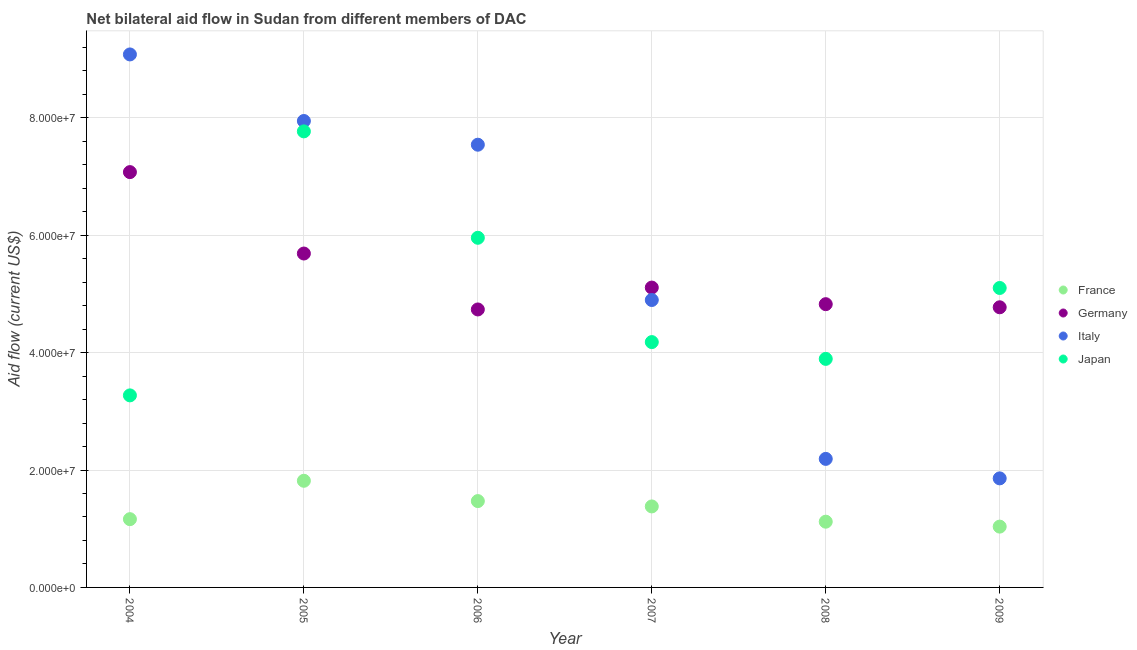How many different coloured dotlines are there?
Ensure brevity in your answer.  4. What is the amount of aid given by germany in 2005?
Your answer should be very brief. 5.69e+07. Across all years, what is the maximum amount of aid given by france?
Your response must be concise. 1.82e+07. Across all years, what is the minimum amount of aid given by germany?
Your answer should be very brief. 4.74e+07. In which year was the amount of aid given by japan maximum?
Give a very brief answer. 2005. What is the total amount of aid given by germany in the graph?
Offer a terse response. 3.22e+08. What is the difference between the amount of aid given by japan in 2005 and that in 2008?
Offer a terse response. 3.88e+07. What is the difference between the amount of aid given by japan in 2008 and the amount of aid given by germany in 2004?
Your answer should be compact. -3.18e+07. What is the average amount of aid given by germany per year?
Your answer should be compact. 5.37e+07. In the year 2004, what is the difference between the amount of aid given by germany and amount of aid given by japan?
Make the answer very short. 3.80e+07. What is the ratio of the amount of aid given by italy in 2006 to that in 2008?
Keep it short and to the point. 3.44. Is the amount of aid given by italy in 2005 less than that in 2006?
Provide a succinct answer. No. What is the difference between the highest and the second highest amount of aid given by germany?
Provide a succinct answer. 1.39e+07. What is the difference between the highest and the lowest amount of aid given by france?
Make the answer very short. 7.81e+06. In how many years, is the amount of aid given by france greater than the average amount of aid given by france taken over all years?
Give a very brief answer. 3. Is it the case that in every year, the sum of the amount of aid given by japan and amount of aid given by france is greater than the sum of amount of aid given by italy and amount of aid given by germany?
Give a very brief answer. No. Does the amount of aid given by japan monotonically increase over the years?
Give a very brief answer. No. How many dotlines are there?
Provide a short and direct response. 4. How many years are there in the graph?
Make the answer very short. 6. Are the values on the major ticks of Y-axis written in scientific E-notation?
Provide a succinct answer. Yes. Does the graph contain grids?
Make the answer very short. Yes. What is the title of the graph?
Your answer should be very brief. Net bilateral aid flow in Sudan from different members of DAC. Does "Secondary vocational education" appear as one of the legend labels in the graph?
Keep it short and to the point. No. What is the Aid flow (current US$) of France in 2004?
Provide a succinct answer. 1.16e+07. What is the Aid flow (current US$) in Germany in 2004?
Offer a terse response. 7.08e+07. What is the Aid flow (current US$) in Italy in 2004?
Make the answer very short. 9.08e+07. What is the Aid flow (current US$) in Japan in 2004?
Provide a succinct answer. 3.27e+07. What is the Aid flow (current US$) of France in 2005?
Your answer should be very brief. 1.82e+07. What is the Aid flow (current US$) in Germany in 2005?
Ensure brevity in your answer.  5.69e+07. What is the Aid flow (current US$) of Italy in 2005?
Provide a short and direct response. 7.95e+07. What is the Aid flow (current US$) of Japan in 2005?
Your response must be concise. 7.77e+07. What is the Aid flow (current US$) in France in 2006?
Make the answer very short. 1.47e+07. What is the Aid flow (current US$) of Germany in 2006?
Provide a short and direct response. 4.74e+07. What is the Aid flow (current US$) of Italy in 2006?
Ensure brevity in your answer.  7.54e+07. What is the Aid flow (current US$) in Japan in 2006?
Provide a short and direct response. 5.96e+07. What is the Aid flow (current US$) in France in 2007?
Offer a very short reply. 1.38e+07. What is the Aid flow (current US$) in Germany in 2007?
Give a very brief answer. 5.11e+07. What is the Aid flow (current US$) of Italy in 2007?
Give a very brief answer. 4.90e+07. What is the Aid flow (current US$) of Japan in 2007?
Provide a short and direct response. 4.18e+07. What is the Aid flow (current US$) in France in 2008?
Provide a succinct answer. 1.12e+07. What is the Aid flow (current US$) in Germany in 2008?
Provide a short and direct response. 4.83e+07. What is the Aid flow (current US$) of Italy in 2008?
Your answer should be compact. 2.19e+07. What is the Aid flow (current US$) in Japan in 2008?
Offer a terse response. 3.89e+07. What is the Aid flow (current US$) of France in 2009?
Give a very brief answer. 1.04e+07. What is the Aid flow (current US$) of Germany in 2009?
Offer a terse response. 4.77e+07. What is the Aid flow (current US$) of Italy in 2009?
Offer a very short reply. 1.86e+07. What is the Aid flow (current US$) of Japan in 2009?
Keep it short and to the point. 5.10e+07. Across all years, what is the maximum Aid flow (current US$) of France?
Keep it short and to the point. 1.82e+07. Across all years, what is the maximum Aid flow (current US$) in Germany?
Provide a short and direct response. 7.08e+07. Across all years, what is the maximum Aid flow (current US$) in Italy?
Provide a succinct answer. 9.08e+07. Across all years, what is the maximum Aid flow (current US$) in Japan?
Make the answer very short. 7.77e+07. Across all years, what is the minimum Aid flow (current US$) of France?
Ensure brevity in your answer.  1.04e+07. Across all years, what is the minimum Aid flow (current US$) in Germany?
Provide a short and direct response. 4.74e+07. Across all years, what is the minimum Aid flow (current US$) of Italy?
Offer a terse response. 1.86e+07. Across all years, what is the minimum Aid flow (current US$) in Japan?
Ensure brevity in your answer.  3.27e+07. What is the total Aid flow (current US$) of France in the graph?
Provide a short and direct response. 7.99e+07. What is the total Aid flow (current US$) of Germany in the graph?
Provide a short and direct response. 3.22e+08. What is the total Aid flow (current US$) in Italy in the graph?
Your response must be concise. 3.35e+08. What is the total Aid flow (current US$) of Japan in the graph?
Your response must be concise. 3.02e+08. What is the difference between the Aid flow (current US$) in France in 2004 and that in 2005?
Provide a short and direct response. -6.54e+06. What is the difference between the Aid flow (current US$) of Germany in 2004 and that in 2005?
Give a very brief answer. 1.39e+07. What is the difference between the Aid flow (current US$) in Italy in 2004 and that in 2005?
Make the answer very short. 1.13e+07. What is the difference between the Aid flow (current US$) of Japan in 2004 and that in 2005?
Keep it short and to the point. -4.50e+07. What is the difference between the Aid flow (current US$) of France in 2004 and that in 2006?
Your answer should be very brief. -3.08e+06. What is the difference between the Aid flow (current US$) in Germany in 2004 and that in 2006?
Your answer should be compact. 2.34e+07. What is the difference between the Aid flow (current US$) of Italy in 2004 and that in 2006?
Your answer should be compact. 1.54e+07. What is the difference between the Aid flow (current US$) in Japan in 2004 and that in 2006?
Offer a very short reply. -2.68e+07. What is the difference between the Aid flow (current US$) of France in 2004 and that in 2007?
Offer a terse response. -2.17e+06. What is the difference between the Aid flow (current US$) of Germany in 2004 and that in 2007?
Offer a very short reply. 1.97e+07. What is the difference between the Aid flow (current US$) in Italy in 2004 and that in 2007?
Make the answer very short. 4.18e+07. What is the difference between the Aid flow (current US$) of Japan in 2004 and that in 2007?
Your answer should be very brief. -9.08e+06. What is the difference between the Aid flow (current US$) of France in 2004 and that in 2008?
Offer a very short reply. 4.30e+05. What is the difference between the Aid flow (current US$) of Germany in 2004 and that in 2008?
Ensure brevity in your answer.  2.25e+07. What is the difference between the Aid flow (current US$) of Italy in 2004 and that in 2008?
Give a very brief answer. 6.89e+07. What is the difference between the Aid flow (current US$) of Japan in 2004 and that in 2008?
Offer a very short reply. -6.22e+06. What is the difference between the Aid flow (current US$) in France in 2004 and that in 2009?
Give a very brief answer. 1.27e+06. What is the difference between the Aid flow (current US$) in Germany in 2004 and that in 2009?
Provide a succinct answer. 2.30e+07. What is the difference between the Aid flow (current US$) in Italy in 2004 and that in 2009?
Your response must be concise. 7.22e+07. What is the difference between the Aid flow (current US$) of Japan in 2004 and that in 2009?
Keep it short and to the point. -1.83e+07. What is the difference between the Aid flow (current US$) of France in 2005 and that in 2006?
Make the answer very short. 3.46e+06. What is the difference between the Aid flow (current US$) of Germany in 2005 and that in 2006?
Your answer should be compact. 9.53e+06. What is the difference between the Aid flow (current US$) in Italy in 2005 and that in 2006?
Provide a succinct answer. 4.04e+06. What is the difference between the Aid flow (current US$) in Japan in 2005 and that in 2006?
Your answer should be very brief. 1.81e+07. What is the difference between the Aid flow (current US$) in France in 2005 and that in 2007?
Your answer should be very brief. 4.37e+06. What is the difference between the Aid flow (current US$) of Germany in 2005 and that in 2007?
Keep it short and to the point. 5.80e+06. What is the difference between the Aid flow (current US$) in Italy in 2005 and that in 2007?
Make the answer very short. 3.05e+07. What is the difference between the Aid flow (current US$) of Japan in 2005 and that in 2007?
Your answer should be compact. 3.59e+07. What is the difference between the Aid flow (current US$) of France in 2005 and that in 2008?
Your answer should be very brief. 6.97e+06. What is the difference between the Aid flow (current US$) in Germany in 2005 and that in 2008?
Give a very brief answer. 8.63e+06. What is the difference between the Aid flow (current US$) of Italy in 2005 and that in 2008?
Your answer should be very brief. 5.76e+07. What is the difference between the Aid flow (current US$) in Japan in 2005 and that in 2008?
Keep it short and to the point. 3.88e+07. What is the difference between the Aid flow (current US$) of France in 2005 and that in 2009?
Give a very brief answer. 7.81e+06. What is the difference between the Aid flow (current US$) of Germany in 2005 and that in 2009?
Give a very brief answer. 9.16e+06. What is the difference between the Aid flow (current US$) in Italy in 2005 and that in 2009?
Offer a very short reply. 6.09e+07. What is the difference between the Aid flow (current US$) in Japan in 2005 and that in 2009?
Ensure brevity in your answer.  2.67e+07. What is the difference between the Aid flow (current US$) of France in 2006 and that in 2007?
Ensure brevity in your answer.  9.10e+05. What is the difference between the Aid flow (current US$) in Germany in 2006 and that in 2007?
Provide a succinct answer. -3.73e+06. What is the difference between the Aid flow (current US$) of Italy in 2006 and that in 2007?
Offer a terse response. 2.65e+07. What is the difference between the Aid flow (current US$) in Japan in 2006 and that in 2007?
Keep it short and to the point. 1.78e+07. What is the difference between the Aid flow (current US$) in France in 2006 and that in 2008?
Give a very brief answer. 3.51e+06. What is the difference between the Aid flow (current US$) in Germany in 2006 and that in 2008?
Make the answer very short. -9.00e+05. What is the difference between the Aid flow (current US$) in Italy in 2006 and that in 2008?
Offer a very short reply. 5.35e+07. What is the difference between the Aid flow (current US$) in Japan in 2006 and that in 2008?
Provide a short and direct response. 2.06e+07. What is the difference between the Aid flow (current US$) of France in 2006 and that in 2009?
Your answer should be compact. 4.35e+06. What is the difference between the Aid flow (current US$) of Germany in 2006 and that in 2009?
Give a very brief answer. -3.70e+05. What is the difference between the Aid flow (current US$) of Italy in 2006 and that in 2009?
Your response must be concise. 5.68e+07. What is the difference between the Aid flow (current US$) of Japan in 2006 and that in 2009?
Offer a very short reply. 8.55e+06. What is the difference between the Aid flow (current US$) in France in 2007 and that in 2008?
Your answer should be compact. 2.60e+06. What is the difference between the Aid flow (current US$) of Germany in 2007 and that in 2008?
Keep it short and to the point. 2.83e+06. What is the difference between the Aid flow (current US$) in Italy in 2007 and that in 2008?
Offer a terse response. 2.71e+07. What is the difference between the Aid flow (current US$) of Japan in 2007 and that in 2008?
Give a very brief answer. 2.86e+06. What is the difference between the Aid flow (current US$) in France in 2007 and that in 2009?
Give a very brief answer. 3.44e+06. What is the difference between the Aid flow (current US$) of Germany in 2007 and that in 2009?
Your answer should be very brief. 3.36e+06. What is the difference between the Aid flow (current US$) in Italy in 2007 and that in 2009?
Keep it short and to the point. 3.04e+07. What is the difference between the Aid flow (current US$) in Japan in 2007 and that in 2009?
Provide a short and direct response. -9.22e+06. What is the difference between the Aid flow (current US$) in France in 2008 and that in 2009?
Your answer should be compact. 8.40e+05. What is the difference between the Aid flow (current US$) in Germany in 2008 and that in 2009?
Offer a terse response. 5.30e+05. What is the difference between the Aid flow (current US$) of Italy in 2008 and that in 2009?
Your answer should be very brief. 3.32e+06. What is the difference between the Aid flow (current US$) of Japan in 2008 and that in 2009?
Keep it short and to the point. -1.21e+07. What is the difference between the Aid flow (current US$) of France in 2004 and the Aid flow (current US$) of Germany in 2005?
Your answer should be very brief. -4.53e+07. What is the difference between the Aid flow (current US$) of France in 2004 and the Aid flow (current US$) of Italy in 2005?
Ensure brevity in your answer.  -6.78e+07. What is the difference between the Aid flow (current US$) in France in 2004 and the Aid flow (current US$) in Japan in 2005?
Ensure brevity in your answer.  -6.61e+07. What is the difference between the Aid flow (current US$) in Germany in 2004 and the Aid flow (current US$) in Italy in 2005?
Keep it short and to the point. -8.71e+06. What is the difference between the Aid flow (current US$) of Germany in 2004 and the Aid flow (current US$) of Japan in 2005?
Give a very brief answer. -6.94e+06. What is the difference between the Aid flow (current US$) of Italy in 2004 and the Aid flow (current US$) of Japan in 2005?
Give a very brief answer. 1.31e+07. What is the difference between the Aid flow (current US$) of France in 2004 and the Aid flow (current US$) of Germany in 2006?
Your response must be concise. -3.57e+07. What is the difference between the Aid flow (current US$) of France in 2004 and the Aid flow (current US$) of Italy in 2006?
Your response must be concise. -6.38e+07. What is the difference between the Aid flow (current US$) of France in 2004 and the Aid flow (current US$) of Japan in 2006?
Provide a short and direct response. -4.79e+07. What is the difference between the Aid flow (current US$) of Germany in 2004 and the Aid flow (current US$) of Italy in 2006?
Keep it short and to the point. -4.67e+06. What is the difference between the Aid flow (current US$) in Germany in 2004 and the Aid flow (current US$) in Japan in 2006?
Provide a succinct answer. 1.12e+07. What is the difference between the Aid flow (current US$) in Italy in 2004 and the Aid flow (current US$) in Japan in 2006?
Offer a terse response. 3.12e+07. What is the difference between the Aid flow (current US$) of France in 2004 and the Aid flow (current US$) of Germany in 2007?
Give a very brief answer. -3.95e+07. What is the difference between the Aid flow (current US$) of France in 2004 and the Aid flow (current US$) of Italy in 2007?
Your answer should be compact. -3.73e+07. What is the difference between the Aid flow (current US$) of France in 2004 and the Aid flow (current US$) of Japan in 2007?
Your answer should be very brief. -3.02e+07. What is the difference between the Aid flow (current US$) in Germany in 2004 and the Aid flow (current US$) in Italy in 2007?
Give a very brief answer. 2.18e+07. What is the difference between the Aid flow (current US$) in Germany in 2004 and the Aid flow (current US$) in Japan in 2007?
Make the answer very short. 2.90e+07. What is the difference between the Aid flow (current US$) of Italy in 2004 and the Aid flow (current US$) of Japan in 2007?
Provide a succinct answer. 4.90e+07. What is the difference between the Aid flow (current US$) in France in 2004 and the Aid flow (current US$) in Germany in 2008?
Keep it short and to the point. -3.66e+07. What is the difference between the Aid flow (current US$) of France in 2004 and the Aid flow (current US$) of Italy in 2008?
Keep it short and to the point. -1.03e+07. What is the difference between the Aid flow (current US$) of France in 2004 and the Aid flow (current US$) of Japan in 2008?
Offer a terse response. -2.73e+07. What is the difference between the Aid flow (current US$) of Germany in 2004 and the Aid flow (current US$) of Italy in 2008?
Offer a very short reply. 4.89e+07. What is the difference between the Aid flow (current US$) of Germany in 2004 and the Aid flow (current US$) of Japan in 2008?
Keep it short and to the point. 3.18e+07. What is the difference between the Aid flow (current US$) of Italy in 2004 and the Aid flow (current US$) of Japan in 2008?
Your answer should be very brief. 5.19e+07. What is the difference between the Aid flow (current US$) in France in 2004 and the Aid flow (current US$) in Germany in 2009?
Provide a succinct answer. -3.61e+07. What is the difference between the Aid flow (current US$) in France in 2004 and the Aid flow (current US$) in Italy in 2009?
Your response must be concise. -6.95e+06. What is the difference between the Aid flow (current US$) of France in 2004 and the Aid flow (current US$) of Japan in 2009?
Provide a succinct answer. -3.94e+07. What is the difference between the Aid flow (current US$) in Germany in 2004 and the Aid flow (current US$) in Italy in 2009?
Offer a very short reply. 5.22e+07. What is the difference between the Aid flow (current US$) in Germany in 2004 and the Aid flow (current US$) in Japan in 2009?
Provide a short and direct response. 1.97e+07. What is the difference between the Aid flow (current US$) of Italy in 2004 and the Aid flow (current US$) of Japan in 2009?
Keep it short and to the point. 3.98e+07. What is the difference between the Aid flow (current US$) of France in 2005 and the Aid flow (current US$) of Germany in 2006?
Provide a short and direct response. -2.92e+07. What is the difference between the Aid flow (current US$) of France in 2005 and the Aid flow (current US$) of Italy in 2006?
Provide a short and direct response. -5.73e+07. What is the difference between the Aid flow (current US$) in France in 2005 and the Aid flow (current US$) in Japan in 2006?
Provide a succinct answer. -4.14e+07. What is the difference between the Aid flow (current US$) in Germany in 2005 and the Aid flow (current US$) in Italy in 2006?
Offer a terse response. -1.85e+07. What is the difference between the Aid flow (current US$) of Germany in 2005 and the Aid flow (current US$) of Japan in 2006?
Your answer should be compact. -2.68e+06. What is the difference between the Aid flow (current US$) of Italy in 2005 and the Aid flow (current US$) of Japan in 2006?
Offer a terse response. 1.99e+07. What is the difference between the Aid flow (current US$) of France in 2005 and the Aid flow (current US$) of Germany in 2007?
Offer a terse response. -3.29e+07. What is the difference between the Aid flow (current US$) of France in 2005 and the Aid flow (current US$) of Italy in 2007?
Your answer should be very brief. -3.08e+07. What is the difference between the Aid flow (current US$) in France in 2005 and the Aid flow (current US$) in Japan in 2007?
Offer a terse response. -2.36e+07. What is the difference between the Aid flow (current US$) in Germany in 2005 and the Aid flow (current US$) in Italy in 2007?
Keep it short and to the point. 7.92e+06. What is the difference between the Aid flow (current US$) of Germany in 2005 and the Aid flow (current US$) of Japan in 2007?
Offer a very short reply. 1.51e+07. What is the difference between the Aid flow (current US$) of Italy in 2005 and the Aid flow (current US$) of Japan in 2007?
Ensure brevity in your answer.  3.77e+07. What is the difference between the Aid flow (current US$) of France in 2005 and the Aid flow (current US$) of Germany in 2008?
Keep it short and to the point. -3.01e+07. What is the difference between the Aid flow (current US$) in France in 2005 and the Aid flow (current US$) in Italy in 2008?
Offer a very short reply. -3.73e+06. What is the difference between the Aid flow (current US$) in France in 2005 and the Aid flow (current US$) in Japan in 2008?
Your answer should be compact. -2.08e+07. What is the difference between the Aid flow (current US$) of Germany in 2005 and the Aid flow (current US$) of Italy in 2008?
Your answer should be very brief. 3.50e+07. What is the difference between the Aid flow (current US$) in Germany in 2005 and the Aid flow (current US$) in Japan in 2008?
Keep it short and to the point. 1.80e+07. What is the difference between the Aid flow (current US$) of Italy in 2005 and the Aid flow (current US$) of Japan in 2008?
Give a very brief answer. 4.05e+07. What is the difference between the Aid flow (current US$) of France in 2005 and the Aid flow (current US$) of Germany in 2009?
Make the answer very short. -2.96e+07. What is the difference between the Aid flow (current US$) of France in 2005 and the Aid flow (current US$) of Italy in 2009?
Your response must be concise. -4.10e+05. What is the difference between the Aid flow (current US$) of France in 2005 and the Aid flow (current US$) of Japan in 2009?
Make the answer very short. -3.28e+07. What is the difference between the Aid flow (current US$) of Germany in 2005 and the Aid flow (current US$) of Italy in 2009?
Your answer should be compact. 3.83e+07. What is the difference between the Aid flow (current US$) of Germany in 2005 and the Aid flow (current US$) of Japan in 2009?
Your response must be concise. 5.87e+06. What is the difference between the Aid flow (current US$) in Italy in 2005 and the Aid flow (current US$) in Japan in 2009?
Your response must be concise. 2.84e+07. What is the difference between the Aid flow (current US$) of France in 2006 and the Aid flow (current US$) of Germany in 2007?
Your answer should be compact. -3.64e+07. What is the difference between the Aid flow (current US$) of France in 2006 and the Aid flow (current US$) of Italy in 2007?
Make the answer very short. -3.43e+07. What is the difference between the Aid flow (current US$) of France in 2006 and the Aid flow (current US$) of Japan in 2007?
Ensure brevity in your answer.  -2.71e+07. What is the difference between the Aid flow (current US$) of Germany in 2006 and the Aid flow (current US$) of Italy in 2007?
Make the answer very short. -1.61e+06. What is the difference between the Aid flow (current US$) of Germany in 2006 and the Aid flow (current US$) of Japan in 2007?
Offer a very short reply. 5.56e+06. What is the difference between the Aid flow (current US$) in Italy in 2006 and the Aid flow (current US$) in Japan in 2007?
Offer a very short reply. 3.36e+07. What is the difference between the Aid flow (current US$) in France in 2006 and the Aid flow (current US$) in Germany in 2008?
Your response must be concise. -3.36e+07. What is the difference between the Aid flow (current US$) in France in 2006 and the Aid flow (current US$) in Italy in 2008?
Your answer should be compact. -7.19e+06. What is the difference between the Aid flow (current US$) of France in 2006 and the Aid flow (current US$) of Japan in 2008?
Offer a very short reply. -2.42e+07. What is the difference between the Aid flow (current US$) of Germany in 2006 and the Aid flow (current US$) of Italy in 2008?
Your answer should be very brief. 2.55e+07. What is the difference between the Aid flow (current US$) of Germany in 2006 and the Aid flow (current US$) of Japan in 2008?
Keep it short and to the point. 8.42e+06. What is the difference between the Aid flow (current US$) of Italy in 2006 and the Aid flow (current US$) of Japan in 2008?
Your answer should be compact. 3.65e+07. What is the difference between the Aid flow (current US$) in France in 2006 and the Aid flow (current US$) in Germany in 2009?
Ensure brevity in your answer.  -3.30e+07. What is the difference between the Aid flow (current US$) in France in 2006 and the Aid flow (current US$) in Italy in 2009?
Offer a very short reply. -3.87e+06. What is the difference between the Aid flow (current US$) of France in 2006 and the Aid flow (current US$) of Japan in 2009?
Give a very brief answer. -3.63e+07. What is the difference between the Aid flow (current US$) of Germany in 2006 and the Aid flow (current US$) of Italy in 2009?
Your answer should be compact. 2.88e+07. What is the difference between the Aid flow (current US$) of Germany in 2006 and the Aid flow (current US$) of Japan in 2009?
Your response must be concise. -3.66e+06. What is the difference between the Aid flow (current US$) of Italy in 2006 and the Aid flow (current US$) of Japan in 2009?
Offer a terse response. 2.44e+07. What is the difference between the Aid flow (current US$) in France in 2007 and the Aid flow (current US$) in Germany in 2008?
Your answer should be compact. -3.45e+07. What is the difference between the Aid flow (current US$) in France in 2007 and the Aid flow (current US$) in Italy in 2008?
Provide a succinct answer. -8.10e+06. What is the difference between the Aid flow (current US$) in France in 2007 and the Aid flow (current US$) in Japan in 2008?
Your answer should be very brief. -2.51e+07. What is the difference between the Aid flow (current US$) of Germany in 2007 and the Aid flow (current US$) of Italy in 2008?
Your answer should be compact. 2.92e+07. What is the difference between the Aid flow (current US$) in Germany in 2007 and the Aid flow (current US$) in Japan in 2008?
Ensure brevity in your answer.  1.22e+07. What is the difference between the Aid flow (current US$) in Italy in 2007 and the Aid flow (current US$) in Japan in 2008?
Give a very brief answer. 1.00e+07. What is the difference between the Aid flow (current US$) of France in 2007 and the Aid flow (current US$) of Germany in 2009?
Make the answer very short. -3.39e+07. What is the difference between the Aid flow (current US$) of France in 2007 and the Aid flow (current US$) of Italy in 2009?
Provide a short and direct response. -4.78e+06. What is the difference between the Aid flow (current US$) of France in 2007 and the Aid flow (current US$) of Japan in 2009?
Offer a terse response. -3.72e+07. What is the difference between the Aid flow (current US$) of Germany in 2007 and the Aid flow (current US$) of Italy in 2009?
Give a very brief answer. 3.25e+07. What is the difference between the Aid flow (current US$) of Italy in 2007 and the Aid flow (current US$) of Japan in 2009?
Provide a short and direct response. -2.05e+06. What is the difference between the Aid flow (current US$) of France in 2008 and the Aid flow (current US$) of Germany in 2009?
Provide a succinct answer. -3.65e+07. What is the difference between the Aid flow (current US$) of France in 2008 and the Aid flow (current US$) of Italy in 2009?
Your response must be concise. -7.38e+06. What is the difference between the Aid flow (current US$) in France in 2008 and the Aid flow (current US$) in Japan in 2009?
Give a very brief answer. -3.98e+07. What is the difference between the Aid flow (current US$) in Germany in 2008 and the Aid flow (current US$) in Italy in 2009?
Provide a succinct answer. 2.97e+07. What is the difference between the Aid flow (current US$) of Germany in 2008 and the Aid flow (current US$) of Japan in 2009?
Your answer should be compact. -2.76e+06. What is the difference between the Aid flow (current US$) of Italy in 2008 and the Aid flow (current US$) of Japan in 2009?
Your answer should be very brief. -2.91e+07. What is the average Aid flow (current US$) in France per year?
Provide a succinct answer. 1.33e+07. What is the average Aid flow (current US$) in Germany per year?
Your response must be concise. 5.37e+07. What is the average Aid flow (current US$) of Italy per year?
Offer a very short reply. 5.59e+07. What is the average Aid flow (current US$) in Japan per year?
Ensure brevity in your answer.  5.03e+07. In the year 2004, what is the difference between the Aid flow (current US$) in France and Aid flow (current US$) in Germany?
Give a very brief answer. -5.91e+07. In the year 2004, what is the difference between the Aid flow (current US$) of France and Aid flow (current US$) of Italy?
Your answer should be compact. -7.92e+07. In the year 2004, what is the difference between the Aid flow (current US$) in France and Aid flow (current US$) in Japan?
Keep it short and to the point. -2.11e+07. In the year 2004, what is the difference between the Aid flow (current US$) in Germany and Aid flow (current US$) in Italy?
Ensure brevity in your answer.  -2.00e+07. In the year 2004, what is the difference between the Aid flow (current US$) of Germany and Aid flow (current US$) of Japan?
Provide a succinct answer. 3.80e+07. In the year 2004, what is the difference between the Aid flow (current US$) in Italy and Aid flow (current US$) in Japan?
Your response must be concise. 5.81e+07. In the year 2005, what is the difference between the Aid flow (current US$) in France and Aid flow (current US$) in Germany?
Make the answer very short. -3.87e+07. In the year 2005, what is the difference between the Aid flow (current US$) of France and Aid flow (current US$) of Italy?
Your answer should be very brief. -6.13e+07. In the year 2005, what is the difference between the Aid flow (current US$) of France and Aid flow (current US$) of Japan?
Your answer should be compact. -5.95e+07. In the year 2005, what is the difference between the Aid flow (current US$) of Germany and Aid flow (current US$) of Italy?
Make the answer very short. -2.26e+07. In the year 2005, what is the difference between the Aid flow (current US$) of Germany and Aid flow (current US$) of Japan?
Your answer should be compact. -2.08e+07. In the year 2005, what is the difference between the Aid flow (current US$) in Italy and Aid flow (current US$) in Japan?
Make the answer very short. 1.77e+06. In the year 2006, what is the difference between the Aid flow (current US$) in France and Aid flow (current US$) in Germany?
Your answer should be compact. -3.26e+07. In the year 2006, what is the difference between the Aid flow (current US$) in France and Aid flow (current US$) in Italy?
Your response must be concise. -6.07e+07. In the year 2006, what is the difference between the Aid flow (current US$) of France and Aid flow (current US$) of Japan?
Ensure brevity in your answer.  -4.49e+07. In the year 2006, what is the difference between the Aid flow (current US$) of Germany and Aid flow (current US$) of Italy?
Keep it short and to the point. -2.81e+07. In the year 2006, what is the difference between the Aid flow (current US$) of Germany and Aid flow (current US$) of Japan?
Your answer should be very brief. -1.22e+07. In the year 2006, what is the difference between the Aid flow (current US$) of Italy and Aid flow (current US$) of Japan?
Your answer should be compact. 1.59e+07. In the year 2007, what is the difference between the Aid flow (current US$) in France and Aid flow (current US$) in Germany?
Ensure brevity in your answer.  -3.73e+07. In the year 2007, what is the difference between the Aid flow (current US$) of France and Aid flow (current US$) of Italy?
Give a very brief answer. -3.52e+07. In the year 2007, what is the difference between the Aid flow (current US$) in France and Aid flow (current US$) in Japan?
Offer a very short reply. -2.80e+07. In the year 2007, what is the difference between the Aid flow (current US$) in Germany and Aid flow (current US$) in Italy?
Offer a terse response. 2.12e+06. In the year 2007, what is the difference between the Aid flow (current US$) in Germany and Aid flow (current US$) in Japan?
Ensure brevity in your answer.  9.29e+06. In the year 2007, what is the difference between the Aid flow (current US$) of Italy and Aid flow (current US$) of Japan?
Ensure brevity in your answer.  7.17e+06. In the year 2008, what is the difference between the Aid flow (current US$) in France and Aid flow (current US$) in Germany?
Make the answer very short. -3.71e+07. In the year 2008, what is the difference between the Aid flow (current US$) of France and Aid flow (current US$) of Italy?
Your answer should be compact. -1.07e+07. In the year 2008, what is the difference between the Aid flow (current US$) in France and Aid flow (current US$) in Japan?
Your answer should be compact. -2.77e+07. In the year 2008, what is the difference between the Aid flow (current US$) in Germany and Aid flow (current US$) in Italy?
Ensure brevity in your answer.  2.64e+07. In the year 2008, what is the difference between the Aid flow (current US$) of Germany and Aid flow (current US$) of Japan?
Ensure brevity in your answer.  9.32e+06. In the year 2008, what is the difference between the Aid flow (current US$) of Italy and Aid flow (current US$) of Japan?
Give a very brief answer. -1.70e+07. In the year 2009, what is the difference between the Aid flow (current US$) in France and Aid flow (current US$) in Germany?
Your response must be concise. -3.74e+07. In the year 2009, what is the difference between the Aid flow (current US$) of France and Aid flow (current US$) of Italy?
Provide a succinct answer. -8.22e+06. In the year 2009, what is the difference between the Aid flow (current US$) of France and Aid flow (current US$) of Japan?
Give a very brief answer. -4.07e+07. In the year 2009, what is the difference between the Aid flow (current US$) in Germany and Aid flow (current US$) in Italy?
Make the answer very short. 2.92e+07. In the year 2009, what is the difference between the Aid flow (current US$) of Germany and Aid flow (current US$) of Japan?
Offer a terse response. -3.29e+06. In the year 2009, what is the difference between the Aid flow (current US$) of Italy and Aid flow (current US$) of Japan?
Provide a succinct answer. -3.24e+07. What is the ratio of the Aid flow (current US$) of France in 2004 to that in 2005?
Offer a terse response. 0.64. What is the ratio of the Aid flow (current US$) of Germany in 2004 to that in 2005?
Your answer should be very brief. 1.24. What is the ratio of the Aid flow (current US$) of Italy in 2004 to that in 2005?
Provide a succinct answer. 1.14. What is the ratio of the Aid flow (current US$) of Japan in 2004 to that in 2005?
Provide a short and direct response. 0.42. What is the ratio of the Aid flow (current US$) in France in 2004 to that in 2006?
Provide a succinct answer. 0.79. What is the ratio of the Aid flow (current US$) of Germany in 2004 to that in 2006?
Your response must be concise. 1.49. What is the ratio of the Aid flow (current US$) of Italy in 2004 to that in 2006?
Provide a short and direct response. 1.2. What is the ratio of the Aid flow (current US$) in Japan in 2004 to that in 2006?
Give a very brief answer. 0.55. What is the ratio of the Aid flow (current US$) of France in 2004 to that in 2007?
Your answer should be very brief. 0.84. What is the ratio of the Aid flow (current US$) of Germany in 2004 to that in 2007?
Provide a short and direct response. 1.39. What is the ratio of the Aid flow (current US$) in Italy in 2004 to that in 2007?
Your response must be concise. 1.85. What is the ratio of the Aid flow (current US$) in Japan in 2004 to that in 2007?
Your answer should be compact. 0.78. What is the ratio of the Aid flow (current US$) in France in 2004 to that in 2008?
Provide a short and direct response. 1.04. What is the ratio of the Aid flow (current US$) of Germany in 2004 to that in 2008?
Your answer should be very brief. 1.47. What is the ratio of the Aid flow (current US$) of Italy in 2004 to that in 2008?
Your answer should be very brief. 4.15. What is the ratio of the Aid flow (current US$) in Japan in 2004 to that in 2008?
Offer a terse response. 0.84. What is the ratio of the Aid flow (current US$) of France in 2004 to that in 2009?
Keep it short and to the point. 1.12. What is the ratio of the Aid flow (current US$) in Germany in 2004 to that in 2009?
Keep it short and to the point. 1.48. What is the ratio of the Aid flow (current US$) in Italy in 2004 to that in 2009?
Your response must be concise. 4.89. What is the ratio of the Aid flow (current US$) in Japan in 2004 to that in 2009?
Your answer should be very brief. 0.64. What is the ratio of the Aid flow (current US$) in France in 2005 to that in 2006?
Your answer should be compact. 1.24. What is the ratio of the Aid flow (current US$) of Germany in 2005 to that in 2006?
Make the answer very short. 1.2. What is the ratio of the Aid flow (current US$) in Italy in 2005 to that in 2006?
Ensure brevity in your answer.  1.05. What is the ratio of the Aid flow (current US$) in Japan in 2005 to that in 2006?
Ensure brevity in your answer.  1.3. What is the ratio of the Aid flow (current US$) of France in 2005 to that in 2007?
Provide a succinct answer. 1.32. What is the ratio of the Aid flow (current US$) of Germany in 2005 to that in 2007?
Keep it short and to the point. 1.11. What is the ratio of the Aid flow (current US$) of Italy in 2005 to that in 2007?
Offer a very short reply. 1.62. What is the ratio of the Aid flow (current US$) in Japan in 2005 to that in 2007?
Provide a short and direct response. 1.86. What is the ratio of the Aid flow (current US$) of France in 2005 to that in 2008?
Provide a short and direct response. 1.62. What is the ratio of the Aid flow (current US$) of Germany in 2005 to that in 2008?
Your answer should be very brief. 1.18. What is the ratio of the Aid flow (current US$) of Italy in 2005 to that in 2008?
Give a very brief answer. 3.63. What is the ratio of the Aid flow (current US$) in Japan in 2005 to that in 2008?
Your answer should be compact. 2. What is the ratio of the Aid flow (current US$) in France in 2005 to that in 2009?
Keep it short and to the point. 1.75. What is the ratio of the Aid flow (current US$) in Germany in 2005 to that in 2009?
Your response must be concise. 1.19. What is the ratio of the Aid flow (current US$) of Italy in 2005 to that in 2009?
Offer a very short reply. 4.28. What is the ratio of the Aid flow (current US$) of Japan in 2005 to that in 2009?
Give a very brief answer. 1.52. What is the ratio of the Aid flow (current US$) of France in 2006 to that in 2007?
Your response must be concise. 1.07. What is the ratio of the Aid flow (current US$) in Germany in 2006 to that in 2007?
Your answer should be compact. 0.93. What is the ratio of the Aid flow (current US$) of Italy in 2006 to that in 2007?
Your answer should be very brief. 1.54. What is the ratio of the Aid flow (current US$) in Japan in 2006 to that in 2007?
Provide a succinct answer. 1.43. What is the ratio of the Aid flow (current US$) of France in 2006 to that in 2008?
Ensure brevity in your answer.  1.31. What is the ratio of the Aid flow (current US$) of Germany in 2006 to that in 2008?
Keep it short and to the point. 0.98. What is the ratio of the Aid flow (current US$) of Italy in 2006 to that in 2008?
Keep it short and to the point. 3.44. What is the ratio of the Aid flow (current US$) in Japan in 2006 to that in 2008?
Keep it short and to the point. 1.53. What is the ratio of the Aid flow (current US$) in France in 2006 to that in 2009?
Give a very brief answer. 1.42. What is the ratio of the Aid flow (current US$) of Germany in 2006 to that in 2009?
Offer a terse response. 0.99. What is the ratio of the Aid flow (current US$) in Italy in 2006 to that in 2009?
Your answer should be compact. 4.06. What is the ratio of the Aid flow (current US$) in Japan in 2006 to that in 2009?
Offer a very short reply. 1.17. What is the ratio of the Aid flow (current US$) in France in 2007 to that in 2008?
Offer a terse response. 1.23. What is the ratio of the Aid flow (current US$) of Germany in 2007 to that in 2008?
Provide a short and direct response. 1.06. What is the ratio of the Aid flow (current US$) of Italy in 2007 to that in 2008?
Offer a terse response. 2.24. What is the ratio of the Aid flow (current US$) in Japan in 2007 to that in 2008?
Provide a succinct answer. 1.07. What is the ratio of the Aid flow (current US$) of France in 2007 to that in 2009?
Provide a succinct answer. 1.33. What is the ratio of the Aid flow (current US$) in Germany in 2007 to that in 2009?
Ensure brevity in your answer.  1.07. What is the ratio of the Aid flow (current US$) of Italy in 2007 to that in 2009?
Give a very brief answer. 2.64. What is the ratio of the Aid flow (current US$) of Japan in 2007 to that in 2009?
Make the answer very short. 0.82. What is the ratio of the Aid flow (current US$) of France in 2008 to that in 2009?
Provide a short and direct response. 1.08. What is the ratio of the Aid flow (current US$) in Germany in 2008 to that in 2009?
Provide a short and direct response. 1.01. What is the ratio of the Aid flow (current US$) of Italy in 2008 to that in 2009?
Your answer should be compact. 1.18. What is the ratio of the Aid flow (current US$) of Japan in 2008 to that in 2009?
Provide a short and direct response. 0.76. What is the difference between the highest and the second highest Aid flow (current US$) of France?
Your answer should be very brief. 3.46e+06. What is the difference between the highest and the second highest Aid flow (current US$) in Germany?
Make the answer very short. 1.39e+07. What is the difference between the highest and the second highest Aid flow (current US$) of Italy?
Offer a very short reply. 1.13e+07. What is the difference between the highest and the second highest Aid flow (current US$) of Japan?
Give a very brief answer. 1.81e+07. What is the difference between the highest and the lowest Aid flow (current US$) of France?
Your answer should be very brief. 7.81e+06. What is the difference between the highest and the lowest Aid flow (current US$) of Germany?
Give a very brief answer. 2.34e+07. What is the difference between the highest and the lowest Aid flow (current US$) in Italy?
Make the answer very short. 7.22e+07. What is the difference between the highest and the lowest Aid flow (current US$) of Japan?
Offer a very short reply. 4.50e+07. 